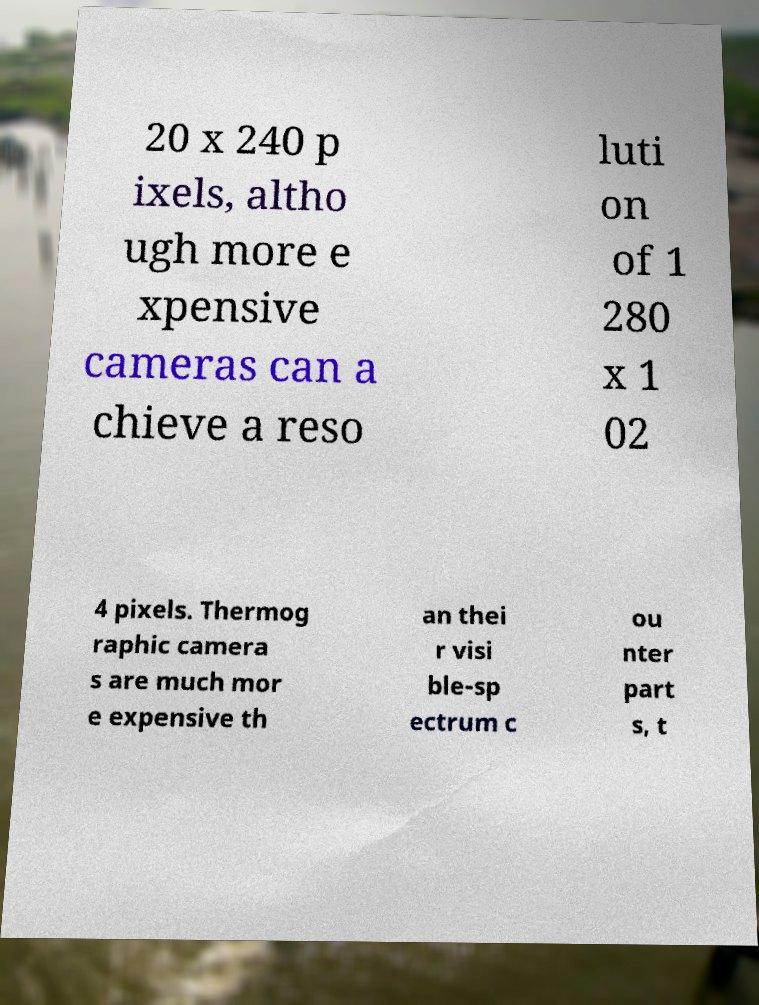I need the written content from this picture converted into text. Can you do that? 20 x 240 p ixels, altho ugh more e xpensive cameras can a chieve a reso luti on of 1 280 x 1 02 4 pixels. Thermog raphic camera s are much mor e expensive th an thei r visi ble-sp ectrum c ou nter part s, t 